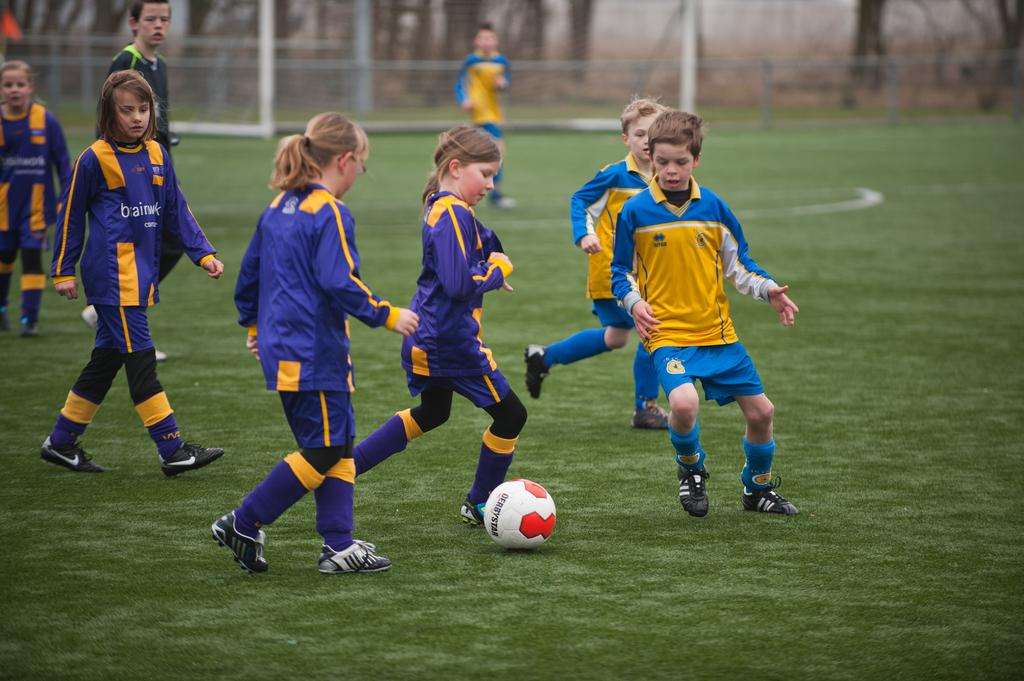What is happening in the image involving the kids? There are many kids playing in the image. How many teams are playing in the image? There are two teams, a blue color team and a violet color team, playing in the image. What are the teams doing in the image? The teams are playing in the image. Can you describe the position of one of the players in the image? There is a goalkeeper standing in the background of the image. How many bikes are parked near the playing area in the image? There is no mention of bikes in the image; it features kids playing a game with two teams. 